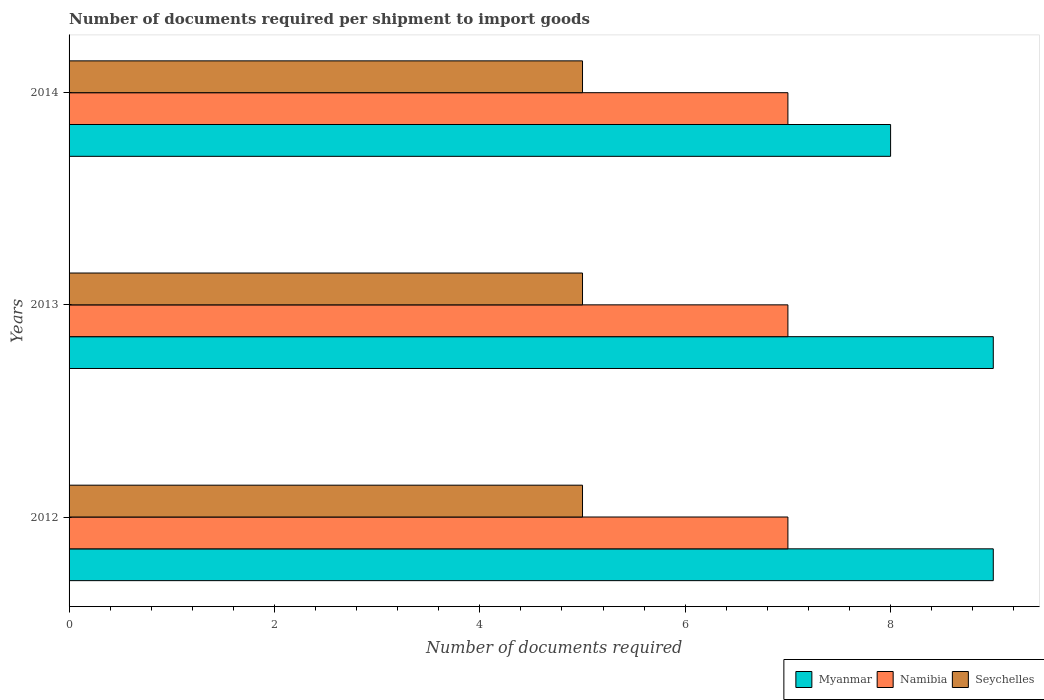Are the number of bars per tick equal to the number of legend labels?
Ensure brevity in your answer.  Yes. Are the number of bars on each tick of the Y-axis equal?
Ensure brevity in your answer.  Yes. How many bars are there on the 1st tick from the top?
Provide a succinct answer. 3. In how many cases, is the number of bars for a given year not equal to the number of legend labels?
Make the answer very short. 0. What is the number of documents required per shipment to import goods in Seychelles in 2012?
Provide a succinct answer. 5. Across all years, what is the maximum number of documents required per shipment to import goods in Myanmar?
Provide a short and direct response. 9. Across all years, what is the minimum number of documents required per shipment to import goods in Myanmar?
Offer a terse response. 8. In which year was the number of documents required per shipment to import goods in Namibia maximum?
Provide a short and direct response. 2012. In which year was the number of documents required per shipment to import goods in Namibia minimum?
Give a very brief answer. 2012. What is the difference between the number of documents required per shipment to import goods in Seychelles in 2014 and the number of documents required per shipment to import goods in Namibia in 2013?
Your answer should be very brief. -2. In how many years, is the number of documents required per shipment to import goods in Seychelles greater than 5.6 ?
Keep it short and to the point. 0. What is the ratio of the number of documents required per shipment to import goods in Seychelles in 2012 to that in 2014?
Provide a short and direct response. 1. Is the number of documents required per shipment to import goods in Namibia in 2013 less than that in 2014?
Make the answer very short. No. What is the difference between the highest and the second highest number of documents required per shipment to import goods in Seychelles?
Keep it short and to the point. 0. What is the difference between the highest and the lowest number of documents required per shipment to import goods in Seychelles?
Offer a terse response. 0. In how many years, is the number of documents required per shipment to import goods in Namibia greater than the average number of documents required per shipment to import goods in Namibia taken over all years?
Offer a very short reply. 0. Is the sum of the number of documents required per shipment to import goods in Seychelles in 2012 and 2013 greater than the maximum number of documents required per shipment to import goods in Namibia across all years?
Give a very brief answer. Yes. What does the 2nd bar from the top in 2012 represents?
Ensure brevity in your answer.  Namibia. What does the 3rd bar from the bottom in 2014 represents?
Your response must be concise. Seychelles. How many bars are there?
Your answer should be very brief. 9. Are all the bars in the graph horizontal?
Your answer should be compact. Yes. How many years are there in the graph?
Offer a very short reply. 3. Where does the legend appear in the graph?
Your answer should be very brief. Bottom right. What is the title of the graph?
Keep it short and to the point. Number of documents required per shipment to import goods. What is the label or title of the X-axis?
Provide a succinct answer. Number of documents required. What is the label or title of the Y-axis?
Your answer should be compact. Years. What is the Number of documents required of Myanmar in 2012?
Make the answer very short. 9. What is the Number of documents required in Seychelles in 2012?
Offer a terse response. 5. What is the Number of documents required in Namibia in 2013?
Your answer should be compact. 7. What is the Number of documents required in Seychelles in 2013?
Your answer should be very brief. 5. What is the Number of documents required in Seychelles in 2014?
Provide a short and direct response. 5. Across all years, what is the maximum Number of documents required of Namibia?
Keep it short and to the point. 7. Across all years, what is the maximum Number of documents required in Seychelles?
Provide a short and direct response. 5. Across all years, what is the minimum Number of documents required of Namibia?
Make the answer very short. 7. Across all years, what is the minimum Number of documents required of Seychelles?
Keep it short and to the point. 5. What is the total Number of documents required of Myanmar in the graph?
Provide a short and direct response. 26. What is the total Number of documents required in Namibia in the graph?
Your response must be concise. 21. What is the difference between the Number of documents required of Myanmar in 2012 and that in 2013?
Give a very brief answer. 0. What is the difference between the Number of documents required of Namibia in 2012 and that in 2013?
Your response must be concise. 0. What is the difference between the Number of documents required of Seychelles in 2012 and that in 2013?
Ensure brevity in your answer.  0. What is the difference between the Number of documents required of Namibia in 2012 and that in 2014?
Your answer should be very brief. 0. What is the difference between the Number of documents required of Seychelles in 2012 and that in 2014?
Your answer should be compact. 0. What is the difference between the Number of documents required in Myanmar in 2013 and that in 2014?
Ensure brevity in your answer.  1. What is the difference between the Number of documents required in Namibia in 2013 and that in 2014?
Ensure brevity in your answer.  0. What is the difference between the Number of documents required of Myanmar in 2012 and the Number of documents required of Namibia in 2013?
Offer a terse response. 2. What is the difference between the Number of documents required of Myanmar in 2012 and the Number of documents required of Seychelles in 2013?
Keep it short and to the point. 4. What is the difference between the Number of documents required in Myanmar in 2012 and the Number of documents required in Seychelles in 2014?
Your answer should be very brief. 4. What is the difference between the Number of documents required of Myanmar in 2013 and the Number of documents required of Namibia in 2014?
Your answer should be compact. 2. What is the difference between the Number of documents required of Myanmar in 2013 and the Number of documents required of Seychelles in 2014?
Provide a short and direct response. 4. What is the difference between the Number of documents required in Namibia in 2013 and the Number of documents required in Seychelles in 2014?
Ensure brevity in your answer.  2. What is the average Number of documents required in Myanmar per year?
Give a very brief answer. 8.67. What is the average Number of documents required of Seychelles per year?
Offer a terse response. 5. In the year 2012, what is the difference between the Number of documents required in Myanmar and Number of documents required in Seychelles?
Ensure brevity in your answer.  4. In the year 2012, what is the difference between the Number of documents required of Namibia and Number of documents required of Seychelles?
Offer a very short reply. 2. In the year 2013, what is the difference between the Number of documents required of Myanmar and Number of documents required of Seychelles?
Provide a succinct answer. 4. In the year 2013, what is the difference between the Number of documents required of Namibia and Number of documents required of Seychelles?
Make the answer very short. 2. In the year 2014, what is the difference between the Number of documents required of Myanmar and Number of documents required of Seychelles?
Make the answer very short. 3. What is the ratio of the Number of documents required in Myanmar in 2012 to that in 2013?
Keep it short and to the point. 1. What is the ratio of the Number of documents required in Namibia in 2012 to that in 2013?
Provide a succinct answer. 1. What is the ratio of the Number of documents required in Seychelles in 2012 to that in 2013?
Offer a terse response. 1. What is the ratio of the Number of documents required of Seychelles in 2012 to that in 2014?
Keep it short and to the point. 1. What is the difference between the highest and the second highest Number of documents required of Myanmar?
Make the answer very short. 0. What is the difference between the highest and the second highest Number of documents required of Namibia?
Your response must be concise. 0. What is the difference between the highest and the lowest Number of documents required in Myanmar?
Provide a succinct answer. 1. What is the difference between the highest and the lowest Number of documents required in Namibia?
Provide a succinct answer. 0. 